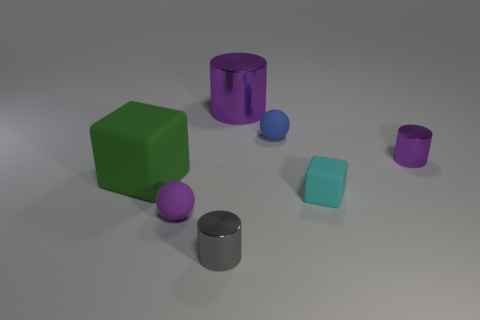Are there any other cylinders that have the same color as the large metallic cylinder?
Offer a very short reply. Yes. Is there a sphere made of the same material as the big green thing?
Your answer should be compact. Yes. What shape is the small matte object that is on the right side of the small purple matte ball and in front of the small blue matte thing?
Your answer should be very brief. Cube. What number of small objects are blue rubber objects or rubber things?
Your response must be concise. 3. What is the material of the tiny cyan cube?
Provide a succinct answer. Rubber. What number of other objects are there of the same shape as the small gray shiny thing?
Offer a very short reply. 2. What is the size of the green rubber cube?
Give a very brief answer. Large. How big is the purple thing that is in front of the blue matte object and behind the purple rubber thing?
Make the answer very short. Small. There is a large object that is left of the gray metallic cylinder; what is its shape?
Make the answer very short. Cube. Do the small gray object and the block that is on the left side of the blue matte thing have the same material?
Your answer should be compact. No. 